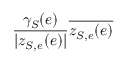<formula> <loc_0><loc_0><loc_500><loc_500>\frac { \gamma _ { S } ( e ) } { | z _ { S , e } ( e ) | } \overline { { z _ { S , e } ( e ) } }</formula> 